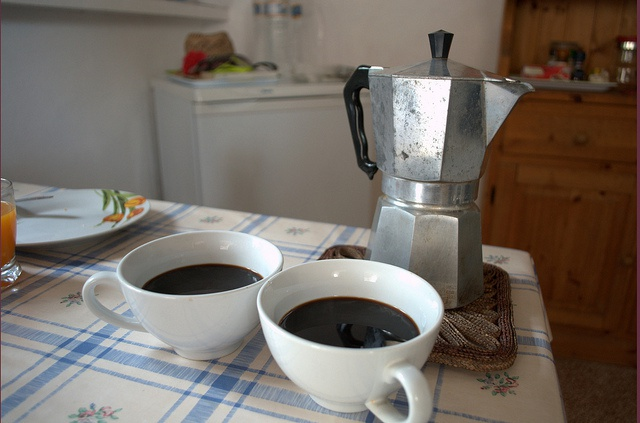Describe the objects in this image and their specific colors. I can see dining table in brown, darkgray, gray, and lightgray tones, refrigerator in brown and gray tones, cup in brown, lightgray, darkgray, black, and gray tones, cup in brown, darkgray, gray, black, and lightgray tones, and cup in brown, maroon, and gray tones in this image. 